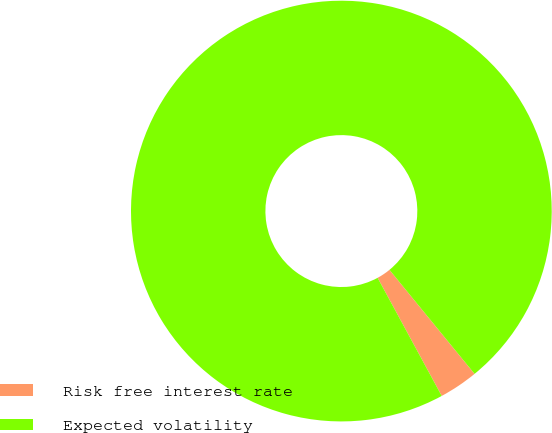Convert chart to OTSL. <chart><loc_0><loc_0><loc_500><loc_500><pie_chart><fcel>Risk free interest rate<fcel>Expected volatility<nl><fcel>3.0%<fcel>97.0%<nl></chart> 